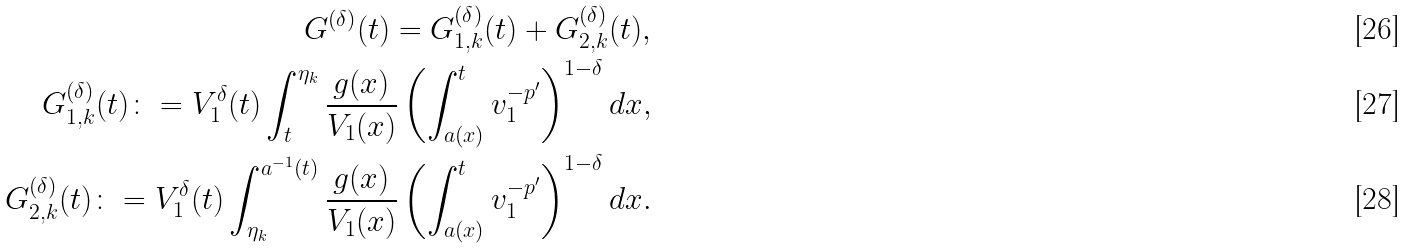Convert formula to latex. <formula><loc_0><loc_0><loc_500><loc_500>G ^ { ( \delta ) } ( t ) = G _ { 1 , k } ^ { ( \delta ) } ( t ) + G _ { 2 , k } ^ { ( \delta ) } ( t ) , \\ G _ { 1 , k } ^ { ( \delta ) } ( t ) \colon = { V ^ { \delta } _ { 1 } ( t ) } \int _ { t } ^ { \eta _ { k } } \frac { g ( x ) } { V _ { 1 } ( x ) } \left ( \int _ { a ( x ) } ^ { t } v _ { 1 } ^ { - p ^ { \prime } } \right ) ^ { 1 - \delta } d x , \\ G _ { 2 , k } ^ { ( \delta ) } ( t ) \colon = { V ^ { \delta } _ { 1 } ( t ) } \int _ { \eta _ { k } } ^ { a ^ { - 1 } ( t ) } \frac { g ( x ) } { V _ { 1 } ( x ) } \left ( \int _ { a ( x ) } ^ { t } v _ { 1 } ^ { - p ^ { \prime } } \right ) ^ { 1 - \delta } d x .</formula> 